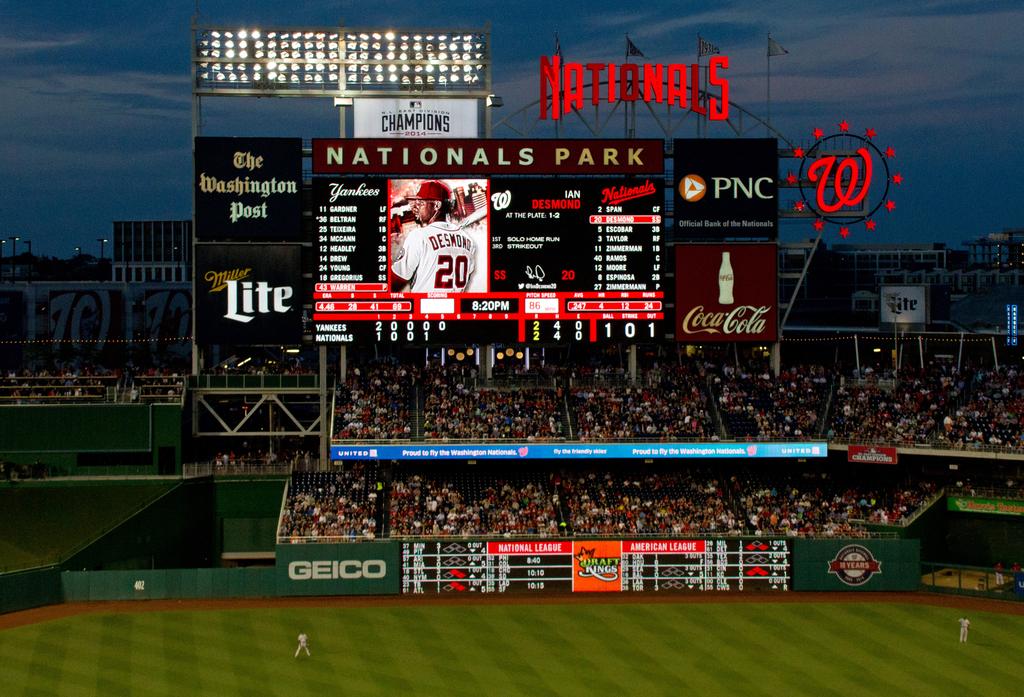What team is the stadium for?
Ensure brevity in your answer.  Nationals. 